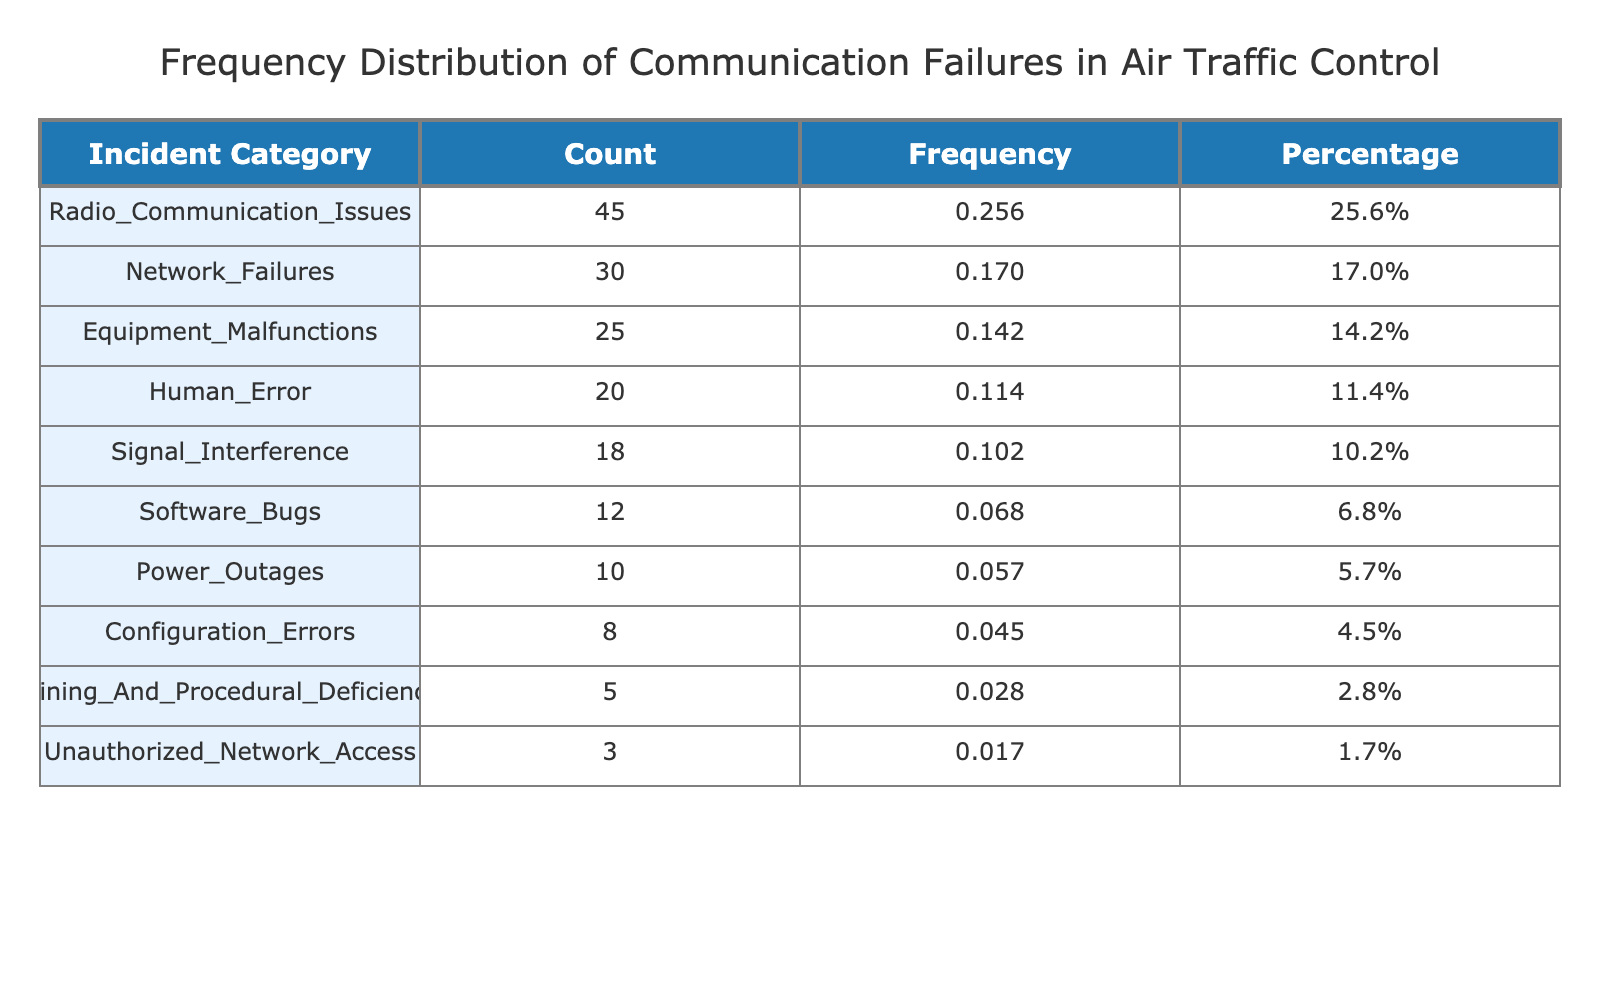What is the total number of incident reports? To find the total number of incident reports, we can sum the counts for each incident category: 45 (Radio Communication Issues) + 30 (Network Failures) + 25 (Equipment Malfunctions) + 20 (Human Error) + 18 (Signal Interference) + 12 (Software Bugs) + 10 (Power Outages) + 8 (Configuration Errors) + 5 (Training And Procedural Deficiencies) + 3 (Unauthorized Network Access) =  176
Answer: 176 Which incident category has the highest count? The highest count is 45, which corresponds to the category "Radio Communication Issues". By scanning the table, we can directly identify this highest value.
Answer: Radio Communication Issues What percentage of the total incidents are caused by Human Error? The count for Human Error is 20. To calculate the percentage of total incidents it represents, we take (20 / 176) * 100 = 11.36, rounded to one decimal place gives us 11.4%.
Answer: 11.4% Are there more incident reports related to Signal Interference than to Power Outages? Signal Interference has a count of 18 incidents while Power Outages has 10. Since 18 is greater than 10, this statement is true.
Answer: Yes What is the combined count of incidents due to Equipment Malfunctions and Software Bugs? Equipment Malfunctions count is 25 and Software Bugs count is 12. To find the combined count: 25 + 12 = 37.
Answer: 37 How many incident categories have a count of less than 10? We review the counts for each category: Configuration Errors (8), Training And Procedural Deficiencies (5), and Unauthorized Network Access (3) are the only categories with counts less than 10. This gives us 3 categories.
Answer: 3 What is the difference between the count of Network Failures and Configuration Errors? Network Failures has a count of 30 and Configuration Errors has a count of 8. To find the difference, we subtract: 30 - 8 = 22.
Answer: 22 Which category has exactly 12 incident reports? By reviewing the incident counts in the table, we see that the category "Software Bugs" has 12 incident reports.
Answer: Software Bugs What is the average count of incidents across all reported categories? The total number of incidents is 176, and there are 10 categories listed. To find the average, we divide the total by the number of categories: 176 / 10 = 17.6.
Answer: 17.6 